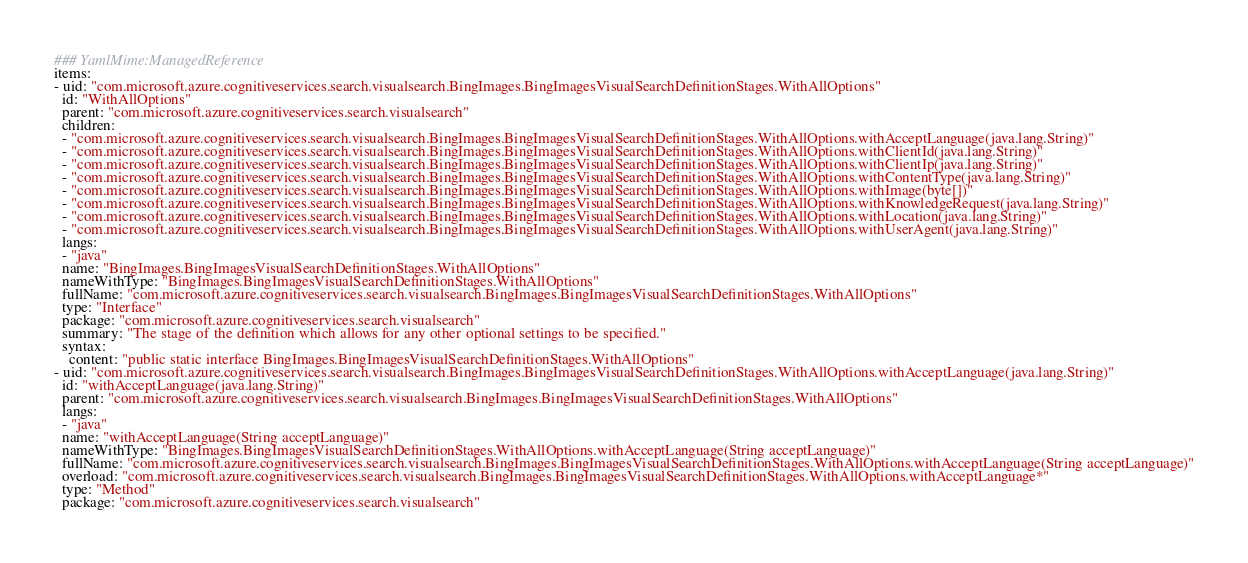Convert code to text. <code><loc_0><loc_0><loc_500><loc_500><_YAML_>### YamlMime:ManagedReference
items:
- uid: "com.microsoft.azure.cognitiveservices.search.visualsearch.BingImages.BingImagesVisualSearchDefinitionStages.WithAllOptions"
  id: "WithAllOptions"
  parent: "com.microsoft.azure.cognitiveservices.search.visualsearch"
  children:
  - "com.microsoft.azure.cognitiveservices.search.visualsearch.BingImages.BingImagesVisualSearchDefinitionStages.WithAllOptions.withAcceptLanguage(java.lang.String)"
  - "com.microsoft.azure.cognitiveservices.search.visualsearch.BingImages.BingImagesVisualSearchDefinitionStages.WithAllOptions.withClientId(java.lang.String)"
  - "com.microsoft.azure.cognitiveservices.search.visualsearch.BingImages.BingImagesVisualSearchDefinitionStages.WithAllOptions.withClientIp(java.lang.String)"
  - "com.microsoft.azure.cognitiveservices.search.visualsearch.BingImages.BingImagesVisualSearchDefinitionStages.WithAllOptions.withContentType(java.lang.String)"
  - "com.microsoft.azure.cognitiveservices.search.visualsearch.BingImages.BingImagesVisualSearchDefinitionStages.WithAllOptions.withImage(byte[])"
  - "com.microsoft.azure.cognitiveservices.search.visualsearch.BingImages.BingImagesVisualSearchDefinitionStages.WithAllOptions.withKnowledgeRequest(java.lang.String)"
  - "com.microsoft.azure.cognitiveservices.search.visualsearch.BingImages.BingImagesVisualSearchDefinitionStages.WithAllOptions.withLocation(java.lang.String)"
  - "com.microsoft.azure.cognitiveservices.search.visualsearch.BingImages.BingImagesVisualSearchDefinitionStages.WithAllOptions.withUserAgent(java.lang.String)"
  langs:
  - "java"
  name: "BingImages.BingImagesVisualSearchDefinitionStages.WithAllOptions"
  nameWithType: "BingImages.BingImagesVisualSearchDefinitionStages.WithAllOptions"
  fullName: "com.microsoft.azure.cognitiveservices.search.visualsearch.BingImages.BingImagesVisualSearchDefinitionStages.WithAllOptions"
  type: "Interface"
  package: "com.microsoft.azure.cognitiveservices.search.visualsearch"
  summary: "The stage of the definition which allows for any other optional settings to be specified."
  syntax:
    content: "public static interface BingImages.BingImagesVisualSearchDefinitionStages.WithAllOptions"
- uid: "com.microsoft.azure.cognitiveservices.search.visualsearch.BingImages.BingImagesVisualSearchDefinitionStages.WithAllOptions.withAcceptLanguage(java.lang.String)"
  id: "withAcceptLanguage(java.lang.String)"
  parent: "com.microsoft.azure.cognitiveservices.search.visualsearch.BingImages.BingImagesVisualSearchDefinitionStages.WithAllOptions"
  langs:
  - "java"
  name: "withAcceptLanguage(String acceptLanguage)"
  nameWithType: "BingImages.BingImagesVisualSearchDefinitionStages.WithAllOptions.withAcceptLanguage(String acceptLanguage)"
  fullName: "com.microsoft.azure.cognitiveservices.search.visualsearch.BingImages.BingImagesVisualSearchDefinitionStages.WithAllOptions.withAcceptLanguage(String acceptLanguage)"
  overload: "com.microsoft.azure.cognitiveservices.search.visualsearch.BingImages.BingImagesVisualSearchDefinitionStages.WithAllOptions.withAcceptLanguage*"
  type: "Method"
  package: "com.microsoft.azure.cognitiveservices.search.visualsearch"</code> 